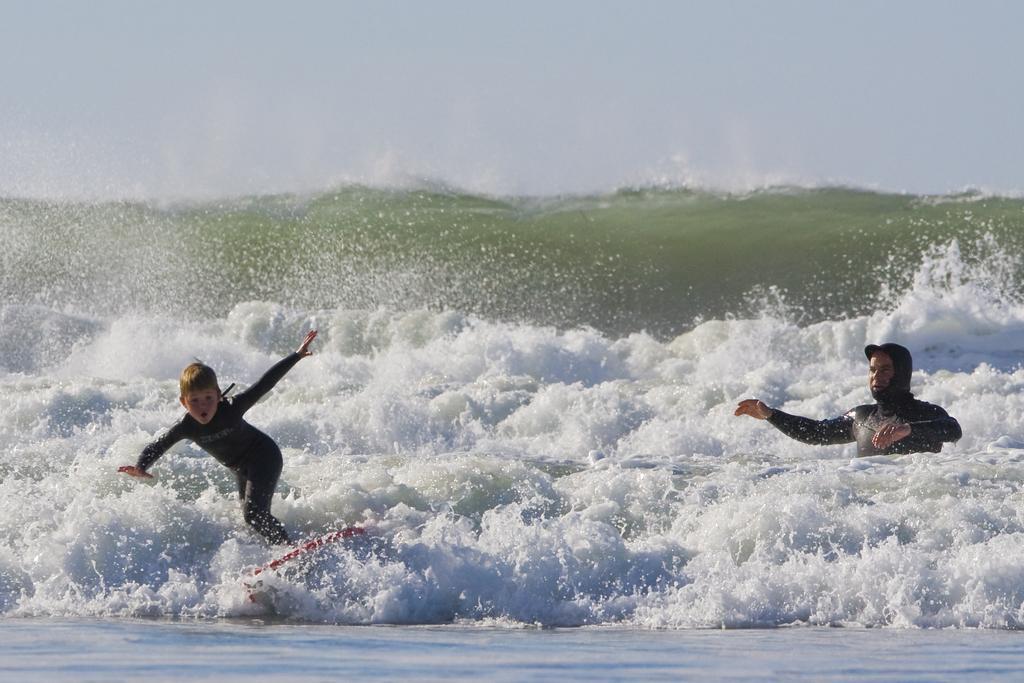Please provide a concise description of this image. In this picture there is a man wearing black color costume in the sea water. Beside there is a small boy wearing a black costume doing a surfing board in the water. Behind there is a sea waves. 